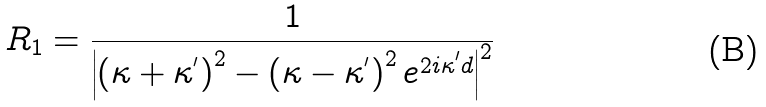<formula> <loc_0><loc_0><loc_500><loc_500>R _ { 1 } = \frac { 1 } { \left | \left ( \kappa + \kappa ^ { ^ { \prime } } \right ) ^ { 2 } - \left ( \kappa - \kappa ^ { ^ { \prime } } \right ) ^ { 2 } e ^ { 2 i \kappa ^ { ^ { \prime } } d } \right | ^ { 2 } } \,</formula> 